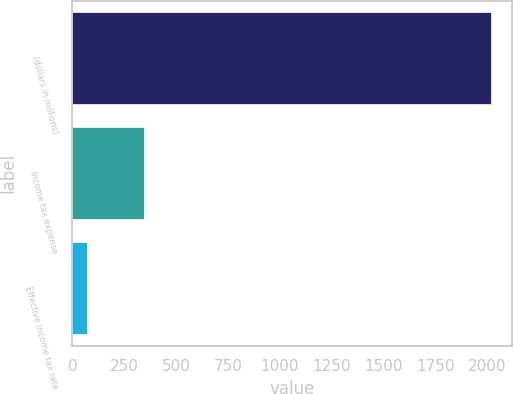Convert chart to OTSL. <chart><loc_0><loc_0><loc_500><loc_500><bar_chart><fcel>(dollars in millions)<fcel>Income tax expense<fcel>Effective income tax rate<nl><fcel>2016<fcel>345<fcel>72<nl></chart> 